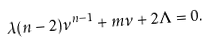<formula> <loc_0><loc_0><loc_500><loc_500>\lambda ( n - 2 ) \nu ^ { n - 1 } + m \nu + 2 \Lambda = 0 .</formula> 